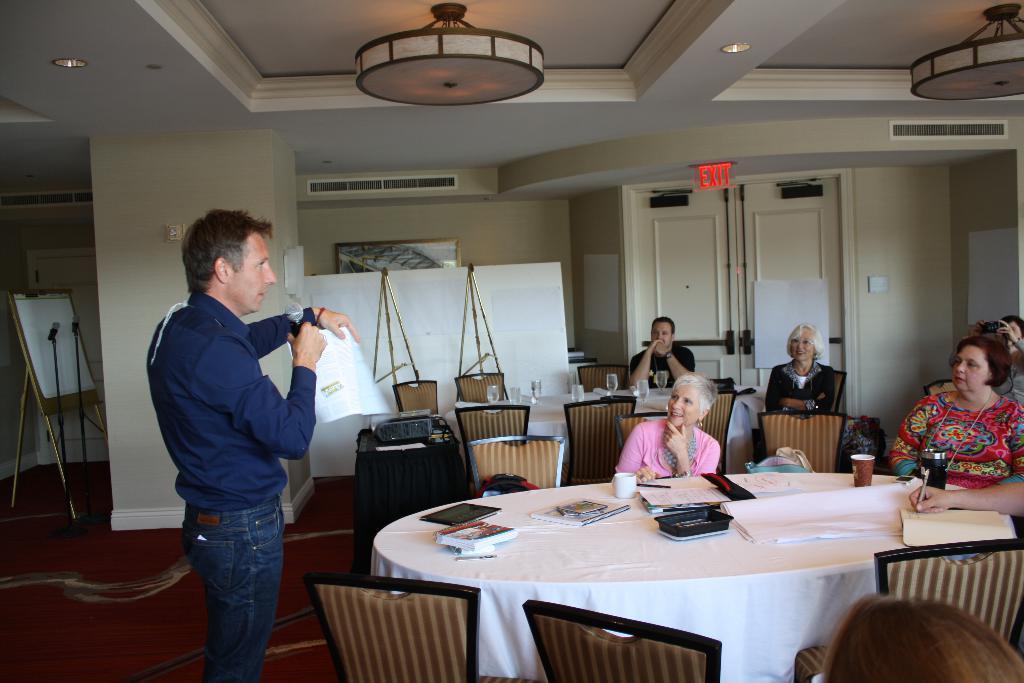Could you give a brief overview of what you see in this image? on the background we can see white board , mike's, door and exit board. This is a ceiling and lights. Here we can see one man standing by holding a mike and a paper in both hands. Here we can see few persons sitting on chairs and on the table we can see gadgets , books,pen , glasses, bottle. These are empty chairs. 